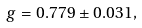<formula> <loc_0><loc_0><loc_500><loc_500>g = 0 . 7 7 9 \pm 0 . 0 3 1 ,</formula> 